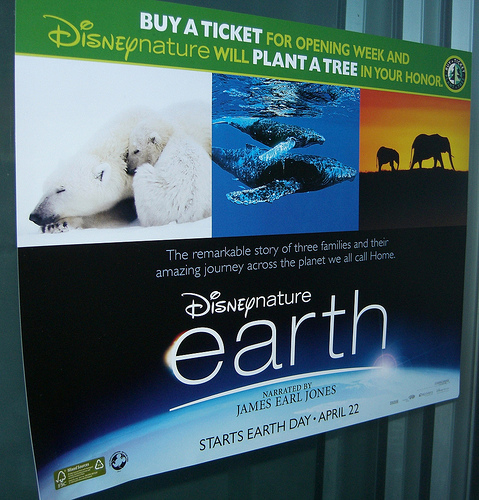<image>
Can you confirm if the earth is under the tree? Yes. The earth is positioned underneath the tree, with the tree above it in the vertical space. Is the polar bear next to the elephant? No. The polar bear is not positioned next to the elephant. They are located in different areas of the scene. 